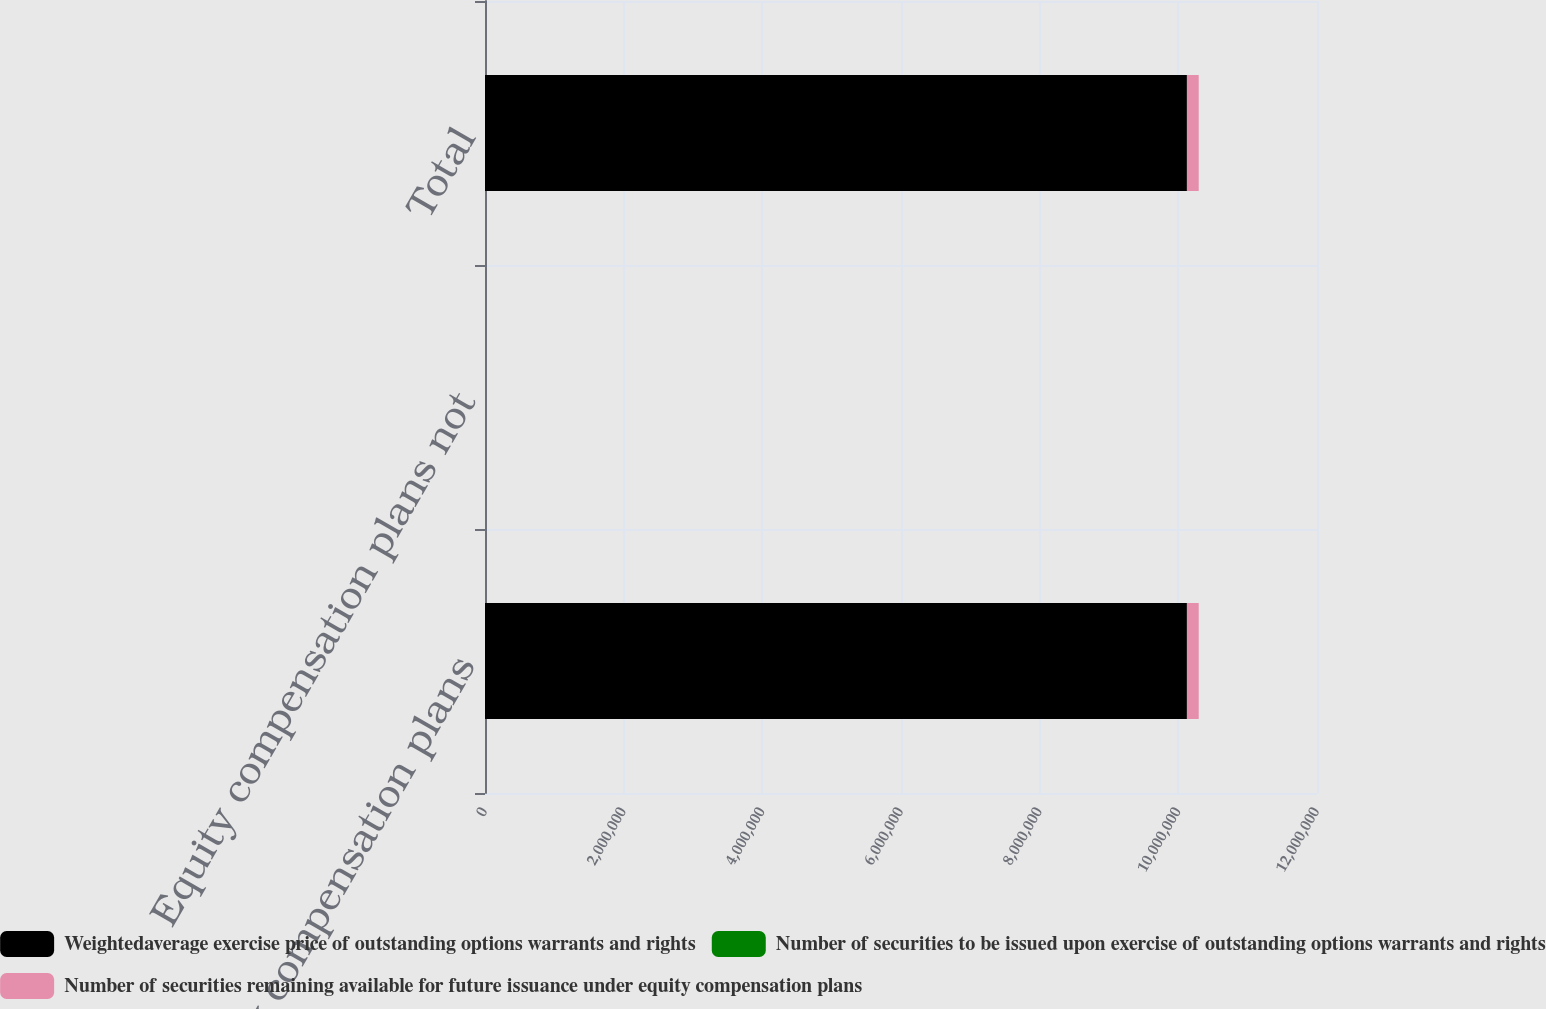Convert chart. <chart><loc_0><loc_0><loc_500><loc_500><stacked_bar_chart><ecel><fcel>Equity compensation plans<fcel>Equity compensation plans not<fcel>Total<nl><fcel>Weightedaverage exercise price of outstanding options warrants and rights<fcel>1.01238e+07<fcel>0<fcel>1.01238e+07<nl><fcel>Number of securities to be issued upon exercise of outstanding options warrants and rights<fcel>51.14<fcel>0<fcel>51.14<nl><fcel>Number of securities remaining available for future issuance under equity compensation plans<fcel>170176<fcel>0<fcel>170176<nl></chart> 